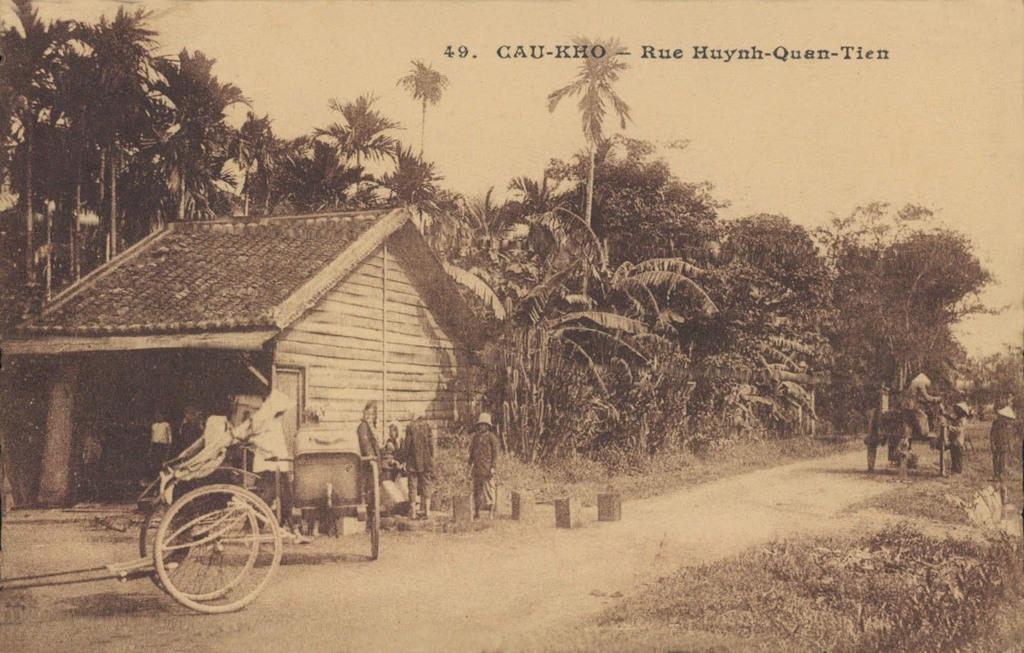What is the color scheme of the image? The picture is black and white. What type of structure can be seen in the image? There is a house in the image. What objects are present in the image that might be used for transportation or carrying items? There are carts in the image. Are there any living beings in the image? Yes, there are people in the image. What type of natural environment is visible in the image? There is grass, trees, and sky visible in the image. Is there any text or writing present in the image? Yes, there is something written on the picture. Can you see the tongue of the person in the image? There is no tongue visible in the image, as it is a black and white picture and does not show any close-up or detailed view of a person's face. --- 